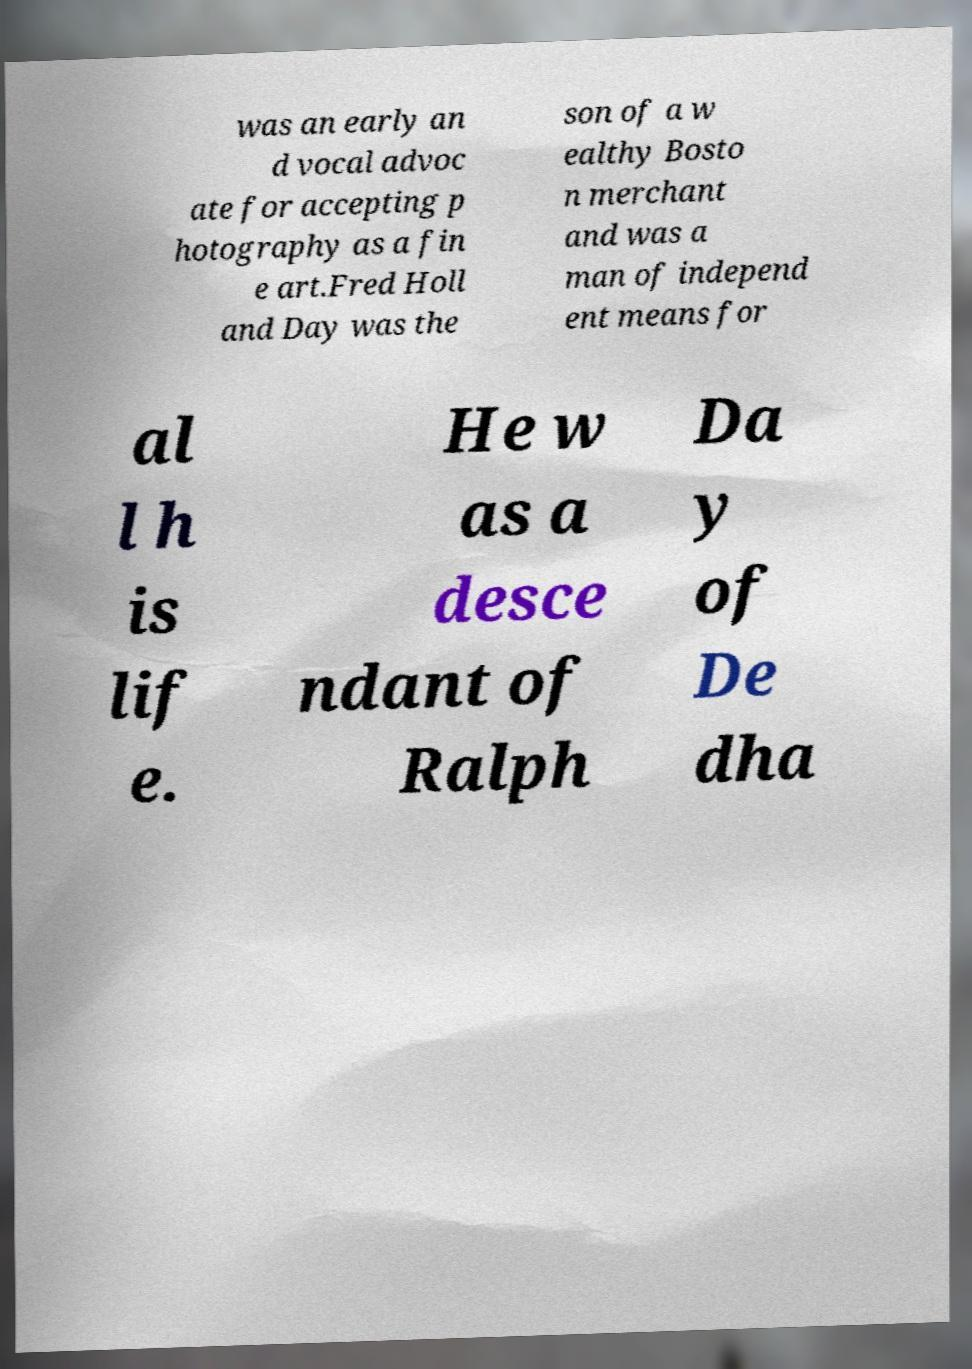Please identify and transcribe the text found in this image. was an early an d vocal advoc ate for accepting p hotography as a fin e art.Fred Holl and Day was the son of a w ealthy Bosto n merchant and was a man of independ ent means for al l h is lif e. He w as a desce ndant of Ralph Da y of De dha 